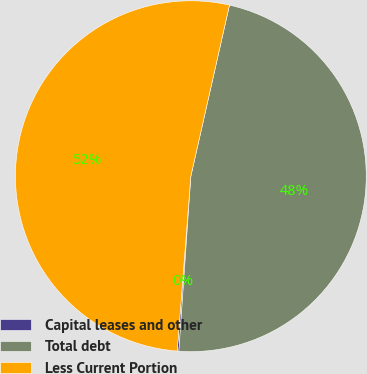Convert chart. <chart><loc_0><loc_0><loc_500><loc_500><pie_chart><fcel>Capital leases and other<fcel>Total debt<fcel>Less Current Portion<nl><fcel>0.15%<fcel>47.55%<fcel>52.29%<nl></chart> 